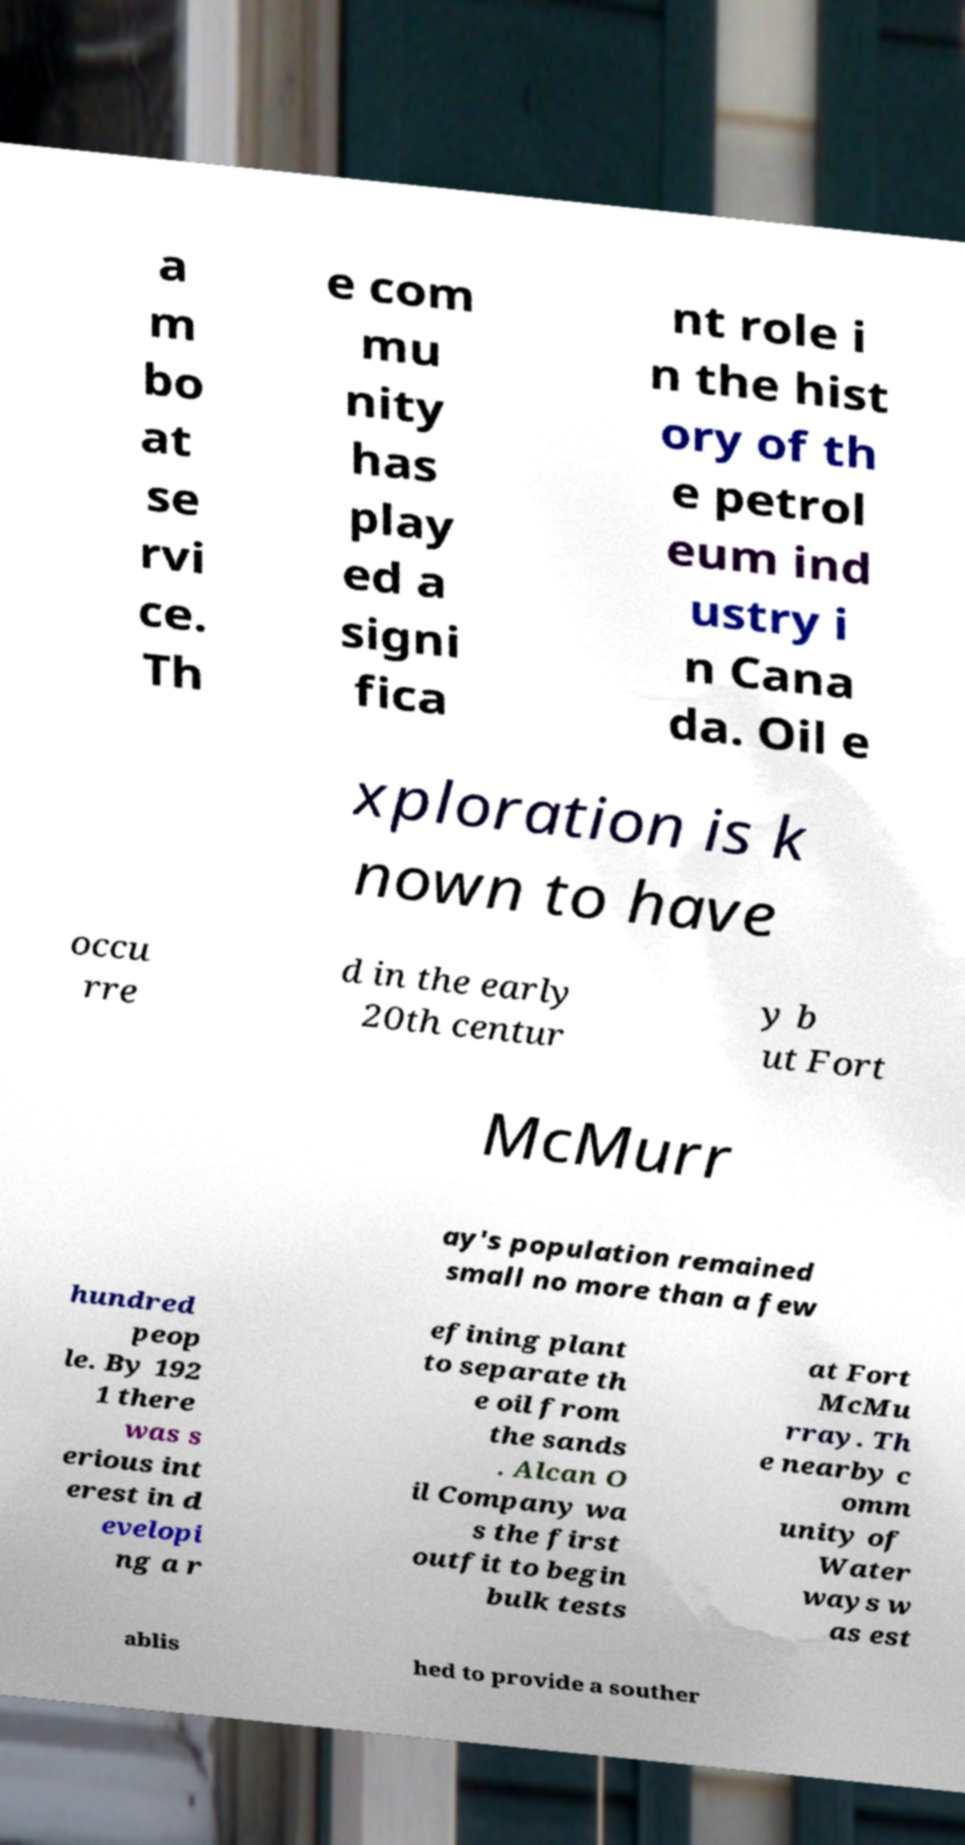Can you accurately transcribe the text from the provided image for me? a m bo at se rvi ce. Th e com mu nity has play ed a signi fica nt role i n the hist ory of th e petrol eum ind ustry i n Cana da. Oil e xploration is k nown to have occu rre d in the early 20th centur y b ut Fort McMurr ay's population remained small no more than a few hundred peop le. By 192 1 there was s erious int erest in d evelopi ng a r efining plant to separate th e oil from the sands . Alcan O il Company wa s the first outfit to begin bulk tests at Fort McMu rray. Th e nearby c omm unity of Water ways w as est ablis hed to provide a souther 